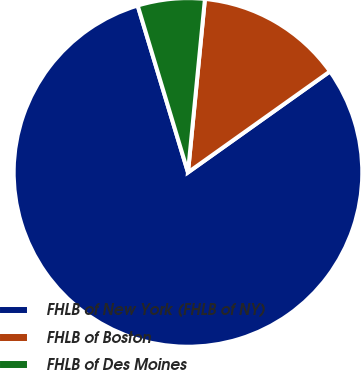<chart> <loc_0><loc_0><loc_500><loc_500><pie_chart><fcel>FHLB of New York (FHLB of NY)<fcel>FHLB of Boston<fcel>FHLB of Des Moines<nl><fcel>80.18%<fcel>13.61%<fcel>6.21%<nl></chart> 